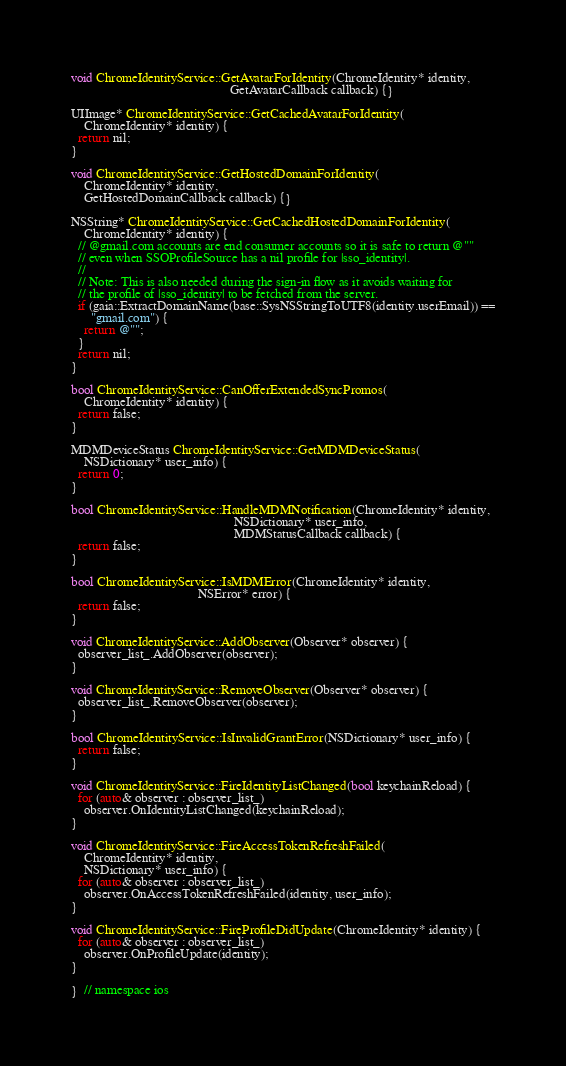Convert code to text. <code><loc_0><loc_0><loc_500><loc_500><_ObjectiveC_>
void ChromeIdentityService::GetAvatarForIdentity(ChromeIdentity* identity,
                                                 GetAvatarCallback callback) {}

UIImage* ChromeIdentityService::GetCachedAvatarForIdentity(
    ChromeIdentity* identity) {
  return nil;
}

void ChromeIdentityService::GetHostedDomainForIdentity(
    ChromeIdentity* identity,
    GetHostedDomainCallback callback) {}

NSString* ChromeIdentityService::GetCachedHostedDomainForIdentity(
    ChromeIdentity* identity) {
  // @gmail.com accounts are end consumer accounts so it is safe to return @""
  // even when SSOProfileSource has a nil profile for |sso_identity|.
  //
  // Note: This is also needed during the sign-in flow as it avoids waiting for
  // the profile of |sso_identity| to be fetched from the server.
  if (gaia::ExtractDomainName(base::SysNSStringToUTF8(identity.userEmail)) ==
      "gmail.com") {
    return @"";
  }
  return nil;
}

bool ChromeIdentityService::CanOfferExtendedSyncPromos(
    ChromeIdentity* identity) {
  return false;
}

MDMDeviceStatus ChromeIdentityService::GetMDMDeviceStatus(
    NSDictionary* user_info) {
  return 0;
}

bool ChromeIdentityService::HandleMDMNotification(ChromeIdentity* identity,
                                                  NSDictionary* user_info,
                                                  MDMStatusCallback callback) {
  return false;
}

bool ChromeIdentityService::IsMDMError(ChromeIdentity* identity,
                                       NSError* error) {
  return false;
}

void ChromeIdentityService::AddObserver(Observer* observer) {
  observer_list_.AddObserver(observer);
}

void ChromeIdentityService::RemoveObserver(Observer* observer) {
  observer_list_.RemoveObserver(observer);
}

bool ChromeIdentityService::IsInvalidGrantError(NSDictionary* user_info) {
  return false;
}

void ChromeIdentityService::FireIdentityListChanged(bool keychainReload) {
  for (auto& observer : observer_list_)
    observer.OnIdentityListChanged(keychainReload);
}

void ChromeIdentityService::FireAccessTokenRefreshFailed(
    ChromeIdentity* identity,
    NSDictionary* user_info) {
  for (auto& observer : observer_list_)
    observer.OnAccessTokenRefreshFailed(identity, user_info);
}

void ChromeIdentityService::FireProfileDidUpdate(ChromeIdentity* identity) {
  for (auto& observer : observer_list_)
    observer.OnProfileUpdate(identity);
}

}  // namespace ios
</code> 